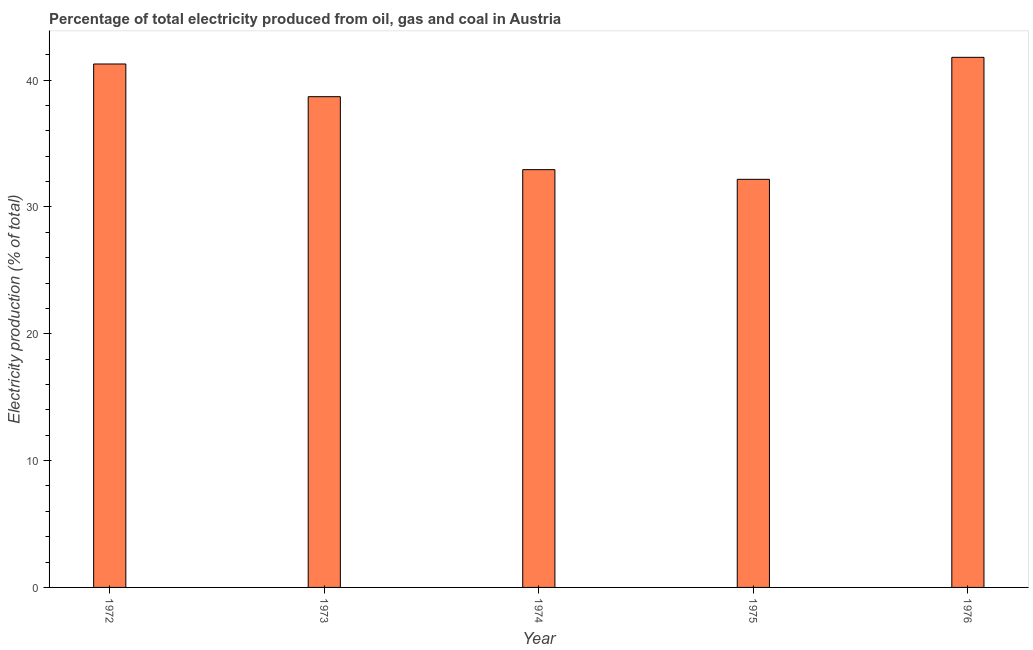Does the graph contain any zero values?
Offer a very short reply. No. Does the graph contain grids?
Your answer should be very brief. No. What is the title of the graph?
Offer a very short reply. Percentage of total electricity produced from oil, gas and coal in Austria. What is the label or title of the Y-axis?
Provide a succinct answer. Electricity production (% of total). What is the electricity production in 1973?
Offer a terse response. 38.7. Across all years, what is the maximum electricity production?
Provide a succinct answer. 41.8. Across all years, what is the minimum electricity production?
Give a very brief answer. 32.18. In which year was the electricity production maximum?
Provide a short and direct response. 1976. In which year was the electricity production minimum?
Offer a terse response. 1975. What is the sum of the electricity production?
Ensure brevity in your answer.  186.9. What is the difference between the electricity production in 1974 and 1976?
Your answer should be very brief. -8.86. What is the average electricity production per year?
Offer a terse response. 37.38. What is the median electricity production?
Ensure brevity in your answer.  38.7. In how many years, is the electricity production greater than 18 %?
Make the answer very short. 5. Do a majority of the years between 1976 and 1975 (inclusive) have electricity production greater than 36 %?
Give a very brief answer. No. What is the ratio of the electricity production in 1972 to that in 1976?
Your answer should be very brief. 0.99. What is the difference between the highest and the second highest electricity production?
Keep it short and to the point. 0.53. Is the sum of the electricity production in 1973 and 1974 greater than the maximum electricity production across all years?
Provide a succinct answer. Yes. What is the difference between the highest and the lowest electricity production?
Your response must be concise. 9.62. Are all the bars in the graph horizontal?
Your answer should be compact. No. How many years are there in the graph?
Provide a short and direct response. 5. What is the difference between two consecutive major ticks on the Y-axis?
Offer a very short reply. 10. What is the Electricity production (% of total) in 1972?
Your answer should be very brief. 41.28. What is the Electricity production (% of total) of 1973?
Keep it short and to the point. 38.7. What is the Electricity production (% of total) in 1974?
Your answer should be very brief. 32.94. What is the Electricity production (% of total) in 1975?
Give a very brief answer. 32.18. What is the Electricity production (% of total) in 1976?
Give a very brief answer. 41.8. What is the difference between the Electricity production (% of total) in 1972 and 1973?
Ensure brevity in your answer.  2.58. What is the difference between the Electricity production (% of total) in 1972 and 1974?
Give a very brief answer. 8.33. What is the difference between the Electricity production (% of total) in 1972 and 1975?
Make the answer very short. 9.09. What is the difference between the Electricity production (% of total) in 1972 and 1976?
Ensure brevity in your answer.  -0.53. What is the difference between the Electricity production (% of total) in 1973 and 1974?
Make the answer very short. 5.75. What is the difference between the Electricity production (% of total) in 1973 and 1975?
Your answer should be compact. 6.52. What is the difference between the Electricity production (% of total) in 1973 and 1976?
Make the answer very short. -3.1. What is the difference between the Electricity production (% of total) in 1974 and 1975?
Your answer should be very brief. 0.76. What is the difference between the Electricity production (% of total) in 1974 and 1976?
Ensure brevity in your answer.  -8.86. What is the difference between the Electricity production (% of total) in 1975 and 1976?
Provide a short and direct response. -9.62. What is the ratio of the Electricity production (% of total) in 1972 to that in 1973?
Provide a succinct answer. 1.07. What is the ratio of the Electricity production (% of total) in 1972 to that in 1974?
Offer a very short reply. 1.25. What is the ratio of the Electricity production (% of total) in 1972 to that in 1975?
Provide a succinct answer. 1.28. What is the ratio of the Electricity production (% of total) in 1972 to that in 1976?
Offer a terse response. 0.99. What is the ratio of the Electricity production (% of total) in 1973 to that in 1974?
Keep it short and to the point. 1.18. What is the ratio of the Electricity production (% of total) in 1973 to that in 1975?
Ensure brevity in your answer.  1.2. What is the ratio of the Electricity production (% of total) in 1973 to that in 1976?
Make the answer very short. 0.93. What is the ratio of the Electricity production (% of total) in 1974 to that in 1975?
Make the answer very short. 1.02. What is the ratio of the Electricity production (% of total) in 1974 to that in 1976?
Offer a very short reply. 0.79. What is the ratio of the Electricity production (% of total) in 1975 to that in 1976?
Keep it short and to the point. 0.77. 